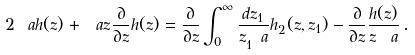Convert formula to latex. <formula><loc_0><loc_0><loc_500><loc_500>2 \ a h ( z ) + \ a z \frac { \partial } { \partial z } h ( z ) = \frac { \partial } { \partial z } \int _ { 0 } ^ { \infty } \frac { d z _ { 1 } } { z _ { 1 } ^ { \ } a } h _ { 2 } ( z , z _ { 1 } ) - \frac { \partial } { \partial z } \frac { h ( z ) } { z ^ { \ } a } \, .</formula> 